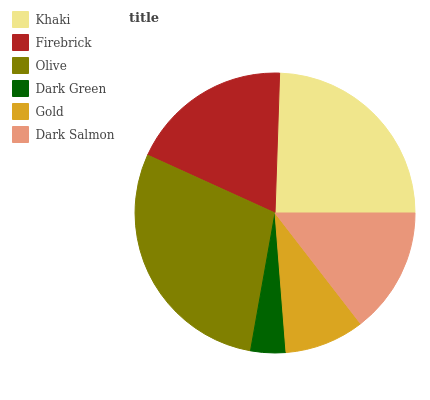Is Dark Green the minimum?
Answer yes or no. Yes. Is Olive the maximum?
Answer yes or no. Yes. Is Firebrick the minimum?
Answer yes or no. No. Is Firebrick the maximum?
Answer yes or no. No. Is Khaki greater than Firebrick?
Answer yes or no. Yes. Is Firebrick less than Khaki?
Answer yes or no. Yes. Is Firebrick greater than Khaki?
Answer yes or no. No. Is Khaki less than Firebrick?
Answer yes or no. No. Is Firebrick the high median?
Answer yes or no. Yes. Is Dark Salmon the low median?
Answer yes or no. Yes. Is Gold the high median?
Answer yes or no. No. Is Khaki the low median?
Answer yes or no. No. 